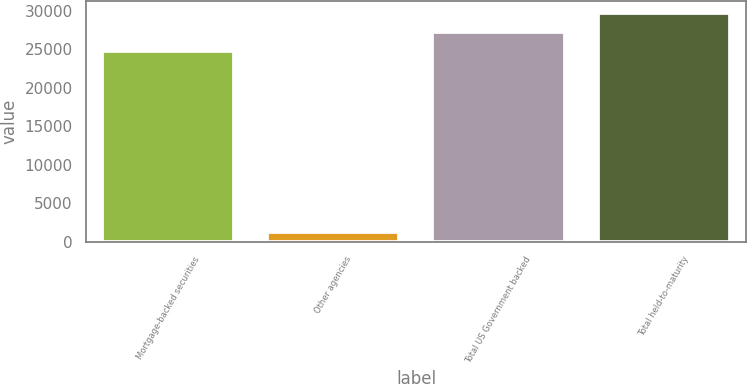<chart> <loc_0><loc_0><loc_500><loc_500><bar_chart><fcel>Mortgage-backed securities<fcel>Other agencies<fcel>Total US Government backed<fcel>Total held-to-maturity<nl><fcel>24832<fcel>1251<fcel>27315.2<fcel>29798.4<nl></chart> 